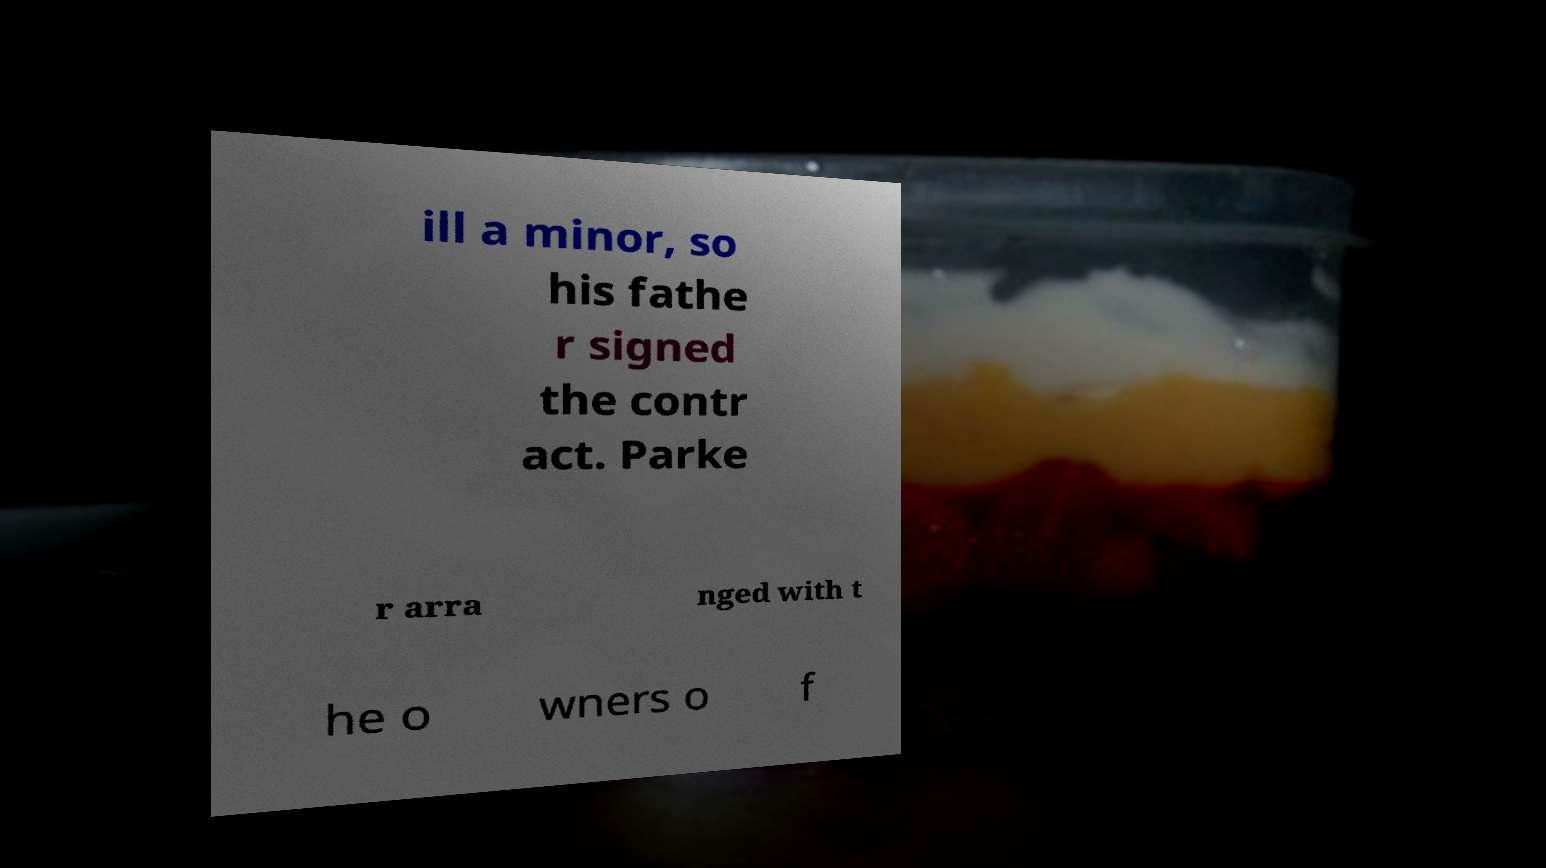Can you read and provide the text displayed in the image?This photo seems to have some interesting text. Can you extract and type it out for me? ill a minor, so his fathe r signed the contr act. Parke r arra nged with t he o wners o f 